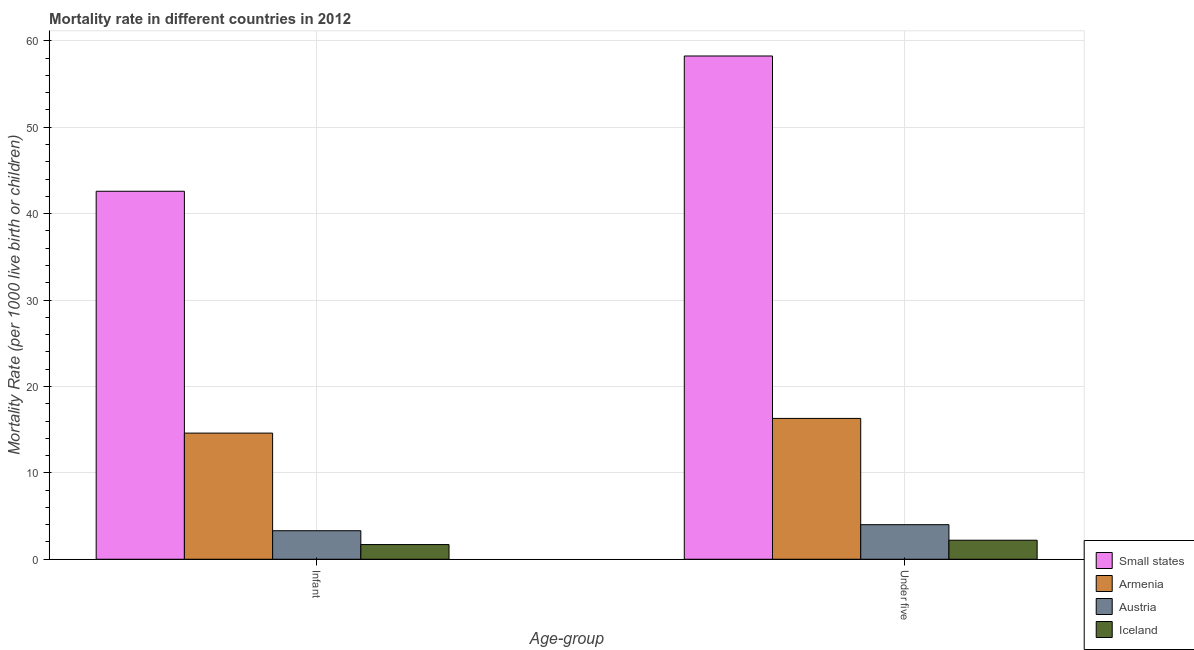How many different coloured bars are there?
Your answer should be compact. 4. How many groups of bars are there?
Keep it short and to the point. 2. How many bars are there on the 2nd tick from the left?
Provide a succinct answer. 4. How many bars are there on the 1st tick from the right?
Give a very brief answer. 4. What is the label of the 1st group of bars from the left?
Ensure brevity in your answer.  Infant. What is the under-5 mortality rate in Small states?
Offer a very short reply. 58.25. Across all countries, what is the maximum under-5 mortality rate?
Provide a short and direct response. 58.25. Across all countries, what is the minimum under-5 mortality rate?
Make the answer very short. 2.2. In which country was the under-5 mortality rate maximum?
Offer a very short reply. Small states. What is the total infant mortality rate in the graph?
Make the answer very short. 62.19. What is the difference between the under-5 mortality rate in Small states and that in Armenia?
Keep it short and to the point. 41.95. What is the difference between the under-5 mortality rate in Armenia and the infant mortality rate in Small states?
Provide a short and direct response. -26.29. What is the average under-5 mortality rate per country?
Ensure brevity in your answer.  20.19. What is the difference between the under-5 mortality rate and infant mortality rate in Small states?
Keep it short and to the point. 15.66. In how many countries, is the under-5 mortality rate greater than 48 ?
Your response must be concise. 1. What is the ratio of the infant mortality rate in Armenia to that in Iceland?
Make the answer very short. 8.59. What does the 3rd bar from the left in Infant represents?
Your answer should be very brief. Austria. What does the 4th bar from the right in Infant represents?
Give a very brief answer. Small states. How many countries are there in the graph?
Your answer should be very brief. 4. Does the graph contain any zero values?
Ensure brevity in your answer.  No. Where does the legend appear in the graph?
Ensure brevity in your answer.  Bottom right. What is the title of the graph?
Make the answer very short. Mortality rate in different countries in 2012. Does "Dominican Republic" appear as one of the legend labels in the graph?
Your answer should be very brief. No. What is the label or title of the X-axis?
Your response must be concise. Age-group. What is the label or title of the Y-axis?
Your answer should be compact. Mortality Rate (per 1000 live birth or children). What is the Mortality Rate (per 1000 live birth or children) of Small states in Infant?
Your answer should be compact. 42.59. What is the Mortality Rate (per 1000 live birth or children) of Armenia in Infant?
Your answer should be compact. 14.6. What is the Mortality Rate (per 1000 live birth or children) of Austria in Infant?
Provide a succinct answer. 3.3. What is the Mortality Rate (per 1000 live birth or children) of Iceland in Infant?
Ensure brevity in your answer.  1.7. What is the Mortality Rate (per 1000 live birth or children) in Small states in Under five?
Your answer should be very brief. 58.25. What is the Mortality Rate (per 1000 live birth or children) of Armenia in Under five?
Provide a succinct answer. 16.3. What is the Mortality Rate (per 1000 live birth or children) of Austria in Under five?
Provide a short and direct response. 4. Across all Age-group, what is the maximum Mortality Rate (per 1000 live birth or children) in Small states?
Your answer should be very brief. 58.25. Across all Age-group, what is the maximum Mortality Rate (per 1000 live birth or children) of Armenia?
Make the answer very short. 16.3. Across all Age-group, what is the maximum Mortality Rate (per 1000 live birth or children) of Iceland?
Your response must be concise. 2.2. Across all Age-group, what is the minimum Mortality Rate (per 1000 live birth or children) of Small states?
Your response must be concise. 42.59. Across all Age-group, what is the minimum Mortality Rate (per 1000 live birth or children) of Armenia?
Provide a succinct answer. 14.6. Across all Age-group, what is the minimum Mortality Rate (per 1000 live birth or children) in Austria?
Give a very brief answer. 3.3. Across all Age-group, what is the minimum Mortality Rate (per 1000 live birth or children) of Iceland?
Your answer should be compact. 1.7. What is the total Mortality Rate (per 1000 live birth or children) in Small states in the graph?
Give a very brief answer. 100.84. What is the total Mortality Rate (per 1000 live birth or children) in Armenia in the graph?
Your response must be concise. 30.9. What is the total Mortality Rate (per 1000 live birth or children) of Austria in the graph?
Offer a very short reply. 7.3. What is the total Mortality Rate (per 1000 live birth or children) of Iceland in the graph?
Provide a succinct answer. 3.9. What is the difference between the Mortality Rate (per 1000 live birth or children) of Small states in Infant and that in Under five?
Offer a terse response. -15.66. What is the difference between the Mortality Rate (per 1000 live birth or children) in Armenia in Infant and that in Under five?
Ensure brevity in your answer.  -1.7. What is the difference between the Mortality Rate (per 1000 live birth or children) of Small states in Infant and the Mortality Rate (per 1000 live birth or children) of Armenia in Under five?
Give a very brief answer. 26.29. What is the difference between the Mortality Rate (per 1000 live birth or children) in Small states in Infant and the Mortality Rate (per 1000 live birth or children) in Austria in Under five?
Offer a very short reply. 38.59. What is the difference between the Mortality Rate (per 1000 live birth or children) of Small states in Infant and the Mortality Rate (per 1000 live birth or children) of Iceland in Under five?
Your answer should be compact. 40.39. What is the difference between the Mortality Rate (per 1000 live birth or children) in Armenia in Infant and the Mortality Rate (per 1000 live birth or children) in Austria in Under five?
Provide a short and direct response. 10.6. What is the difference between the Mortality Rate (per 1000 live birth or children) in Armenia in Infant and the Mortality Rate (per 1000 live birth or children) in Iceland in Under five?
Make the answer very short. 12.4. What is the difference between the Mortality Rate (per 1000 live birth or children) in Austria in Infant and the Mortality Rate (per 1000 live birth or children) in Iceland in Under five?
Make the answer very short. 1.1. What is the average Mortality Rate (per 1000 live birth or children) of Small states per Age-group?
Your answer should be very brief. 50.42. What is the average Mortality Rate (per 1000 live birth or children) of Armenia per Age-group?
Offer a very short reply. 15.45. What is the average Mortality Rate (per 1000 live birth or children) in Austria per Age-group?
Give a very brief answer. 3.65. What is the average Mortality Rate (per 1000 live birth or children) in Iceland per Age-group?
Make the answer very short. 1.95. What is the difference between the Mortality Rate (per 1000 live birth or children) of Small states and Mortality Rate (per 1000 live birth or children) of Armenia in Infant?
Provide a short and direct response. 27.99. What is the difference between the Mortality Rate (per 1000 live birth or children) in Small states and Mortality Rate (per 1000 live birth or children) in Austria in Infant?
Your answer should be compact. 39.29. What is the difference between the Mortality Rate (per 1000 live birth or children) of Small states and Mortality Rate (per 1000 live birth or children) of Iceland in Infant?
Ensure brevity in your answer.  40.89. What is the difference between the Mortality Rate (per 1000 live birth or children) of Armenia and Mortality Rate (per 1000 live birth or children) of Austria in Infant?
Keep it short and to the point. 11.3. What is the difference between the Mortality Rate (per 1000 live birth or children) in Small states and Mortality Rate (per 1000 live birth or children) in Armenia in Under five?
Provide a succinct answer. 41.95. What is the difference between the Mortality Rate (per 1000 live birth or children) in Small states and Mortality Rate (per 1000 live birth or children) in Austria in Under five?
Provide a succinct answer. 54.25. What is the difference between the Mortality Rate (per 1000 live birth or children) in Small states and Mortality Rate (per 1000 live birth or children) in Iceland in Under five?
Offer a terse response. 56.05. What is the difference between the Mortality Rate (per 1000 live birth or children) of Armenia and Mortality Rate (per 1000 live birth or children) of Austria in Under five?
Your response must be concise. 12.3. What is the difference between the Mortality Rate (per 1000 live birth or children) in Austria and Mortality Rate (per 1000 live birth or children) in Iceland in Under five?
Your answer should be very brief. 1.8. What is the ratio of the Mortality Rate (per 1000 live birth or children) of Small states in Infant to that in Under five?
Offer a terse response. 0.73. What is the ratio of the Mortality Rate (per 1000 live birth or children) of Armenia in Infant to that in Under five?
Give a very brief answer. 0.9. What is the ratio of the Mortality Rate (per 1000 live birth or children) of Austria in Infant to that in Under five?
Offer a terse response. 0.82. What is the ratio of the Mortality Rate (per 1000 live birth or children) of Iceland in Infant to that in Under five?
Offer a terse response. 0.77. What is the difference between the highest and the second highest Mortality Rate (per 1000 live birth or children) in Small states?
Provide a succinct answer. 15.66. What is the difference between the highest and the second highest Mortality Rate (per 1000 live birth or children) of Armenia?
Offer a terse response. 1.7. What is the difference between the highest and the second highest Mortality Rate (per 1000 live birth or children) of Iceland?
Make the answer very short. 0.5. What is the difference between the highest and the lowest Mortality Rate (per 1000 live birth or children) of Small states?
Offer a terse response. 15.66. What is the difference between the highest and the lowest Mortality Rate (per 1000 live birth or children) of Armenia?
Give a very brief answer. 1.7. What is the difference between the highest and the lowest Mortality Rate (per 1000 live birth or children) of Austria?
Your response must be concise. 0.7. 